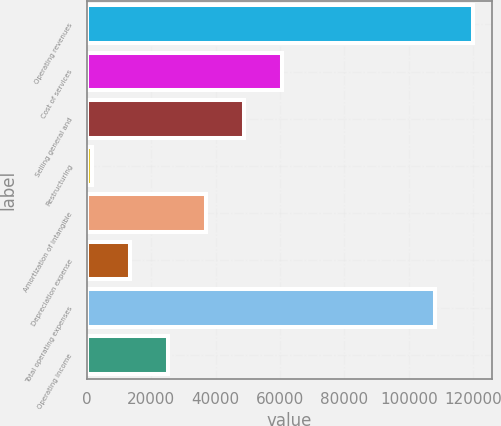<chart> <loc_0><loc_0><loc_500><loc_500><bar_chart><fcel>Operating revenues<fcel>Cost of services<fcel>Selling general and<fcel>Restructuring<fcel>Amortization of intangible<fcel>Depreciation expense<fcel>Total operating expenses<fcel>Operating income<nl><fcel>119886<fcel>60614.5<fcel>48820.2<fcel>1643<fcel>37025.9<fcel>13437.3<fcel>108092<fcel>25231.6<nl></chart> 